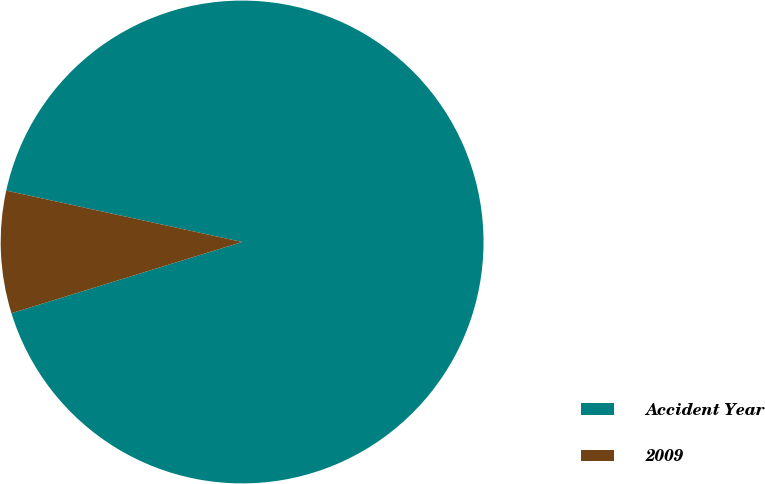Convert chart to OTSL. <chart><loc_0><loc_0><loc_500><loc_500><pie_chart><fcel>Accident Year<fcel>2009<nl><fcel>91.82%<fcel>8.18%<nl></chart> 